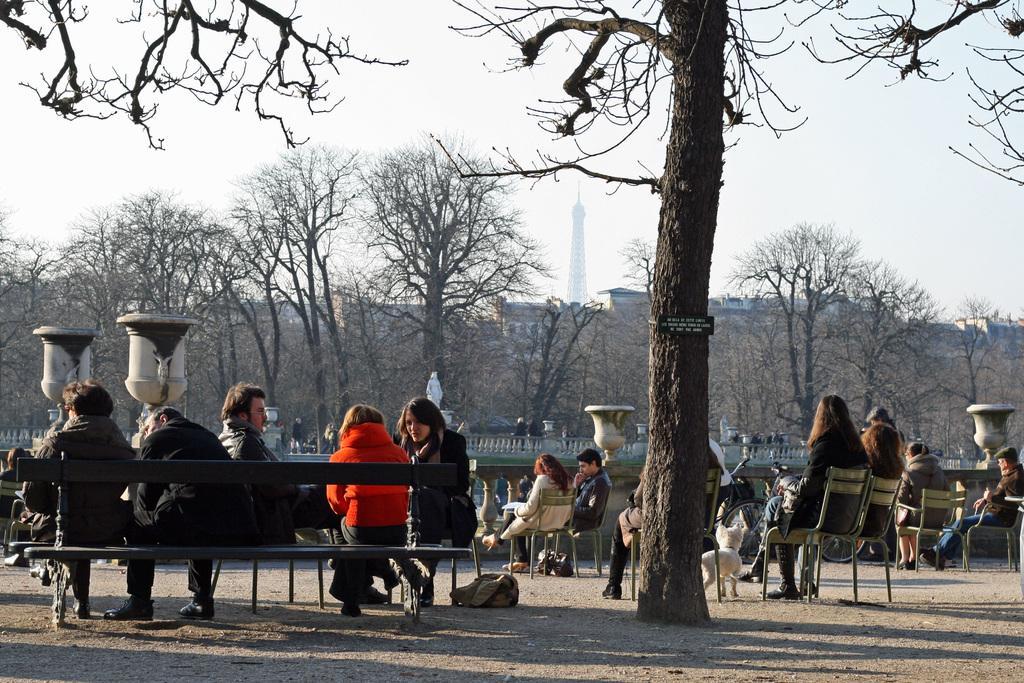How would you summarize this image in a sentence or two? In this image I can see a bench, number of chairs and on it I can see number of people are sitting. On the ground I can see few bags, shadows and a white dog. I can also see number of trees, a white colour sculpture and few other things in the center of the image. In the background I can see number of buildings and the sky. 